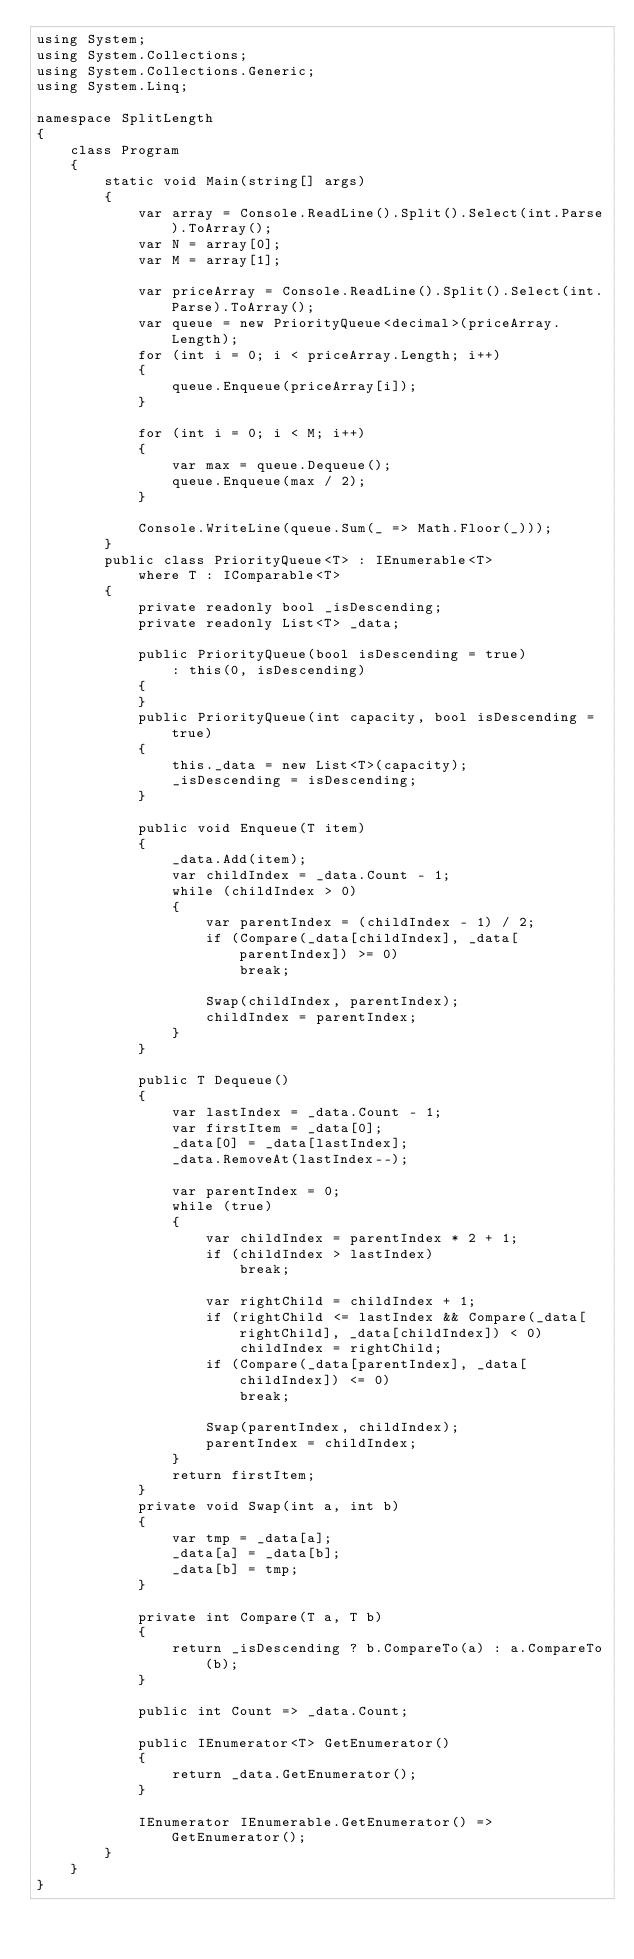<code> <loc_0><loc_0><loc_500><loc_500><_C#_>using System;
using System.Collections;
using System.Collections.Generic;
using System.Linq;

namespace SplitLength
{
    class Program
    {
        static void Main(string[] args)
        {
            var array = Console.ReadLine().Split().Select(int.Parse).ToArray();
            var N = array[0];
            var M = array[1];

            var priceArray = Console.ReadLine().Split().Select(int.Parse).ToArray();
            var queue = new PriorityQueue<decimal>(priceArray.Length);
            for (int i = 0; i < priceArray.Length; i++)
            {
                queue.Enqueue(priceArray[i]);
            }

            for (int i = 0; i < M; i++)
            {
                var max = queue.Dequeue();
                queue.Enqueue(max / 2);
            }

            Console.WriteLine(queue.Sum(_ => Math.Floor(_)));
        }
        public class PriorityQueue<T> : IEnumerable<T>
            where T : IComparable<T>
        {
            private readonly bool _isDescending;
            private readonly List<T> _data;

            public PriorityQueue(bool isDescending = true)
                : this(0, isDescending)
            {
            }
            public PriorityQueue(int capacity, bool isDescending = true)
            {
                this._data = new List<T>(capacity);
                _isDescending = isDescending;
            }

            public void Enqueue(T item)
            {
                _data.Add(item);
                var childIndex = _data.Count - 1;
                while (childIndex > 0)
                {
                    var parentIndex = (childIndex - 1) / 2;
                    if (Compare(_data[childIndex], _data[parentIndex]) >= 0)
                        break;

                    Swap(childIndex, parentIndex);
                    childIndex = parentIndex;
                }
            }

            public T Dequeue()
            {
                var lastIndex = _data.Count - 1;
                var firstItem = _data[0];
                _data[0] = _data[lastIndex];
                _data.RemoveAt(lastIndex--);

                var parentIndex = 0;
                while (true)
                {
                    var childIndex = parentIndex * 2 + 1;
                    if (childIndex > lastIndex)
                        break;

                    var rightChild = childIndex + 1;
                    if (rightChild <= lastIndex && Compare(_data[rightChild], _data[childIndex]) < 0)
                        childIndex = rightChild;
                    if (Compare(_data[parentIndex], _data[childIndex]) <= 0)
                        break;

                    Swap(parentIndex, childIndex);
                    parentIndex = childIndex;
                }
                return firstItem;
            }
            private void Swap(int a, int b)
            {
                var tmp = _data[a];
                _data[a] = _data[b];
                _data[b] = tmp;
            }

            private int Compare(T a, T b)
            {
                return _isDescending ? b.CompareTo(a) : a.CompareTo(b);
            }

            public int Count => _data.Count;

            public IEnumerator<T> GetEnumerator()
            {
                return _data.GetEnumerator();
            }

            IEnumerator IEnumerable.GetEnumerator() => GetEnumerator();
        }
    }
}
</code> 